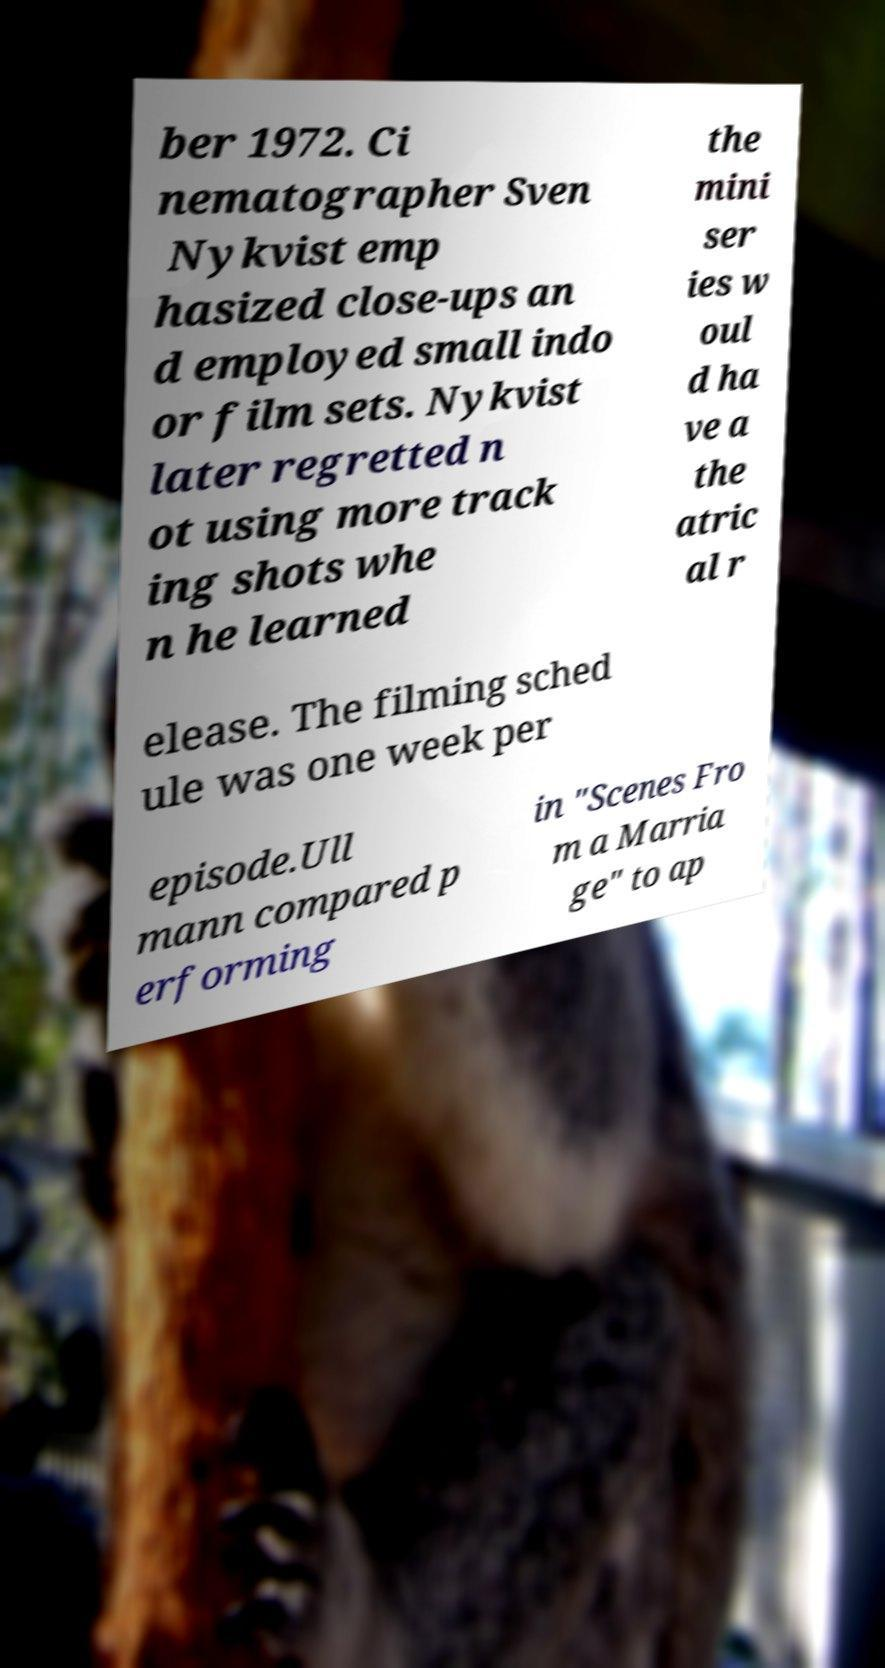Please identify and transcribe the text found in this image. ber 1972. Ci nematographer Sven Nykvist emp hasized close-ups an d employed small indo or film sets. Nykvist later regretted n ot using more track ing shots whe n he learned the mini ser ies w oul d ha ve a the atric al r elease. The filming sched ule was one week per episode.Ull mann compared p erforming in "Scenes Fro m a Marria ge" to ap 